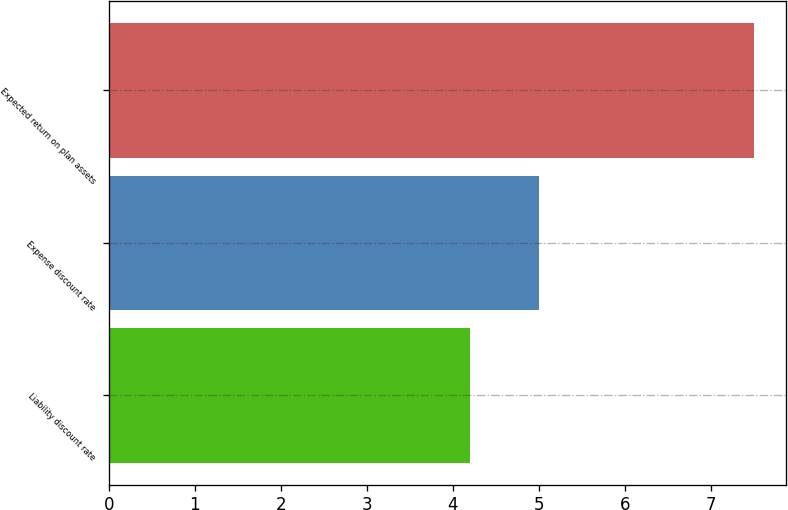<chart> <loc_0><loc_0><loc_500><loc_500><bar_chart><fcel>Liability discount rate<fcel>Expense discount rate<fcel>Expected return on plan assets<nl><fcel>4.2<fcel>5<fcel>7.5<nl></chart> 